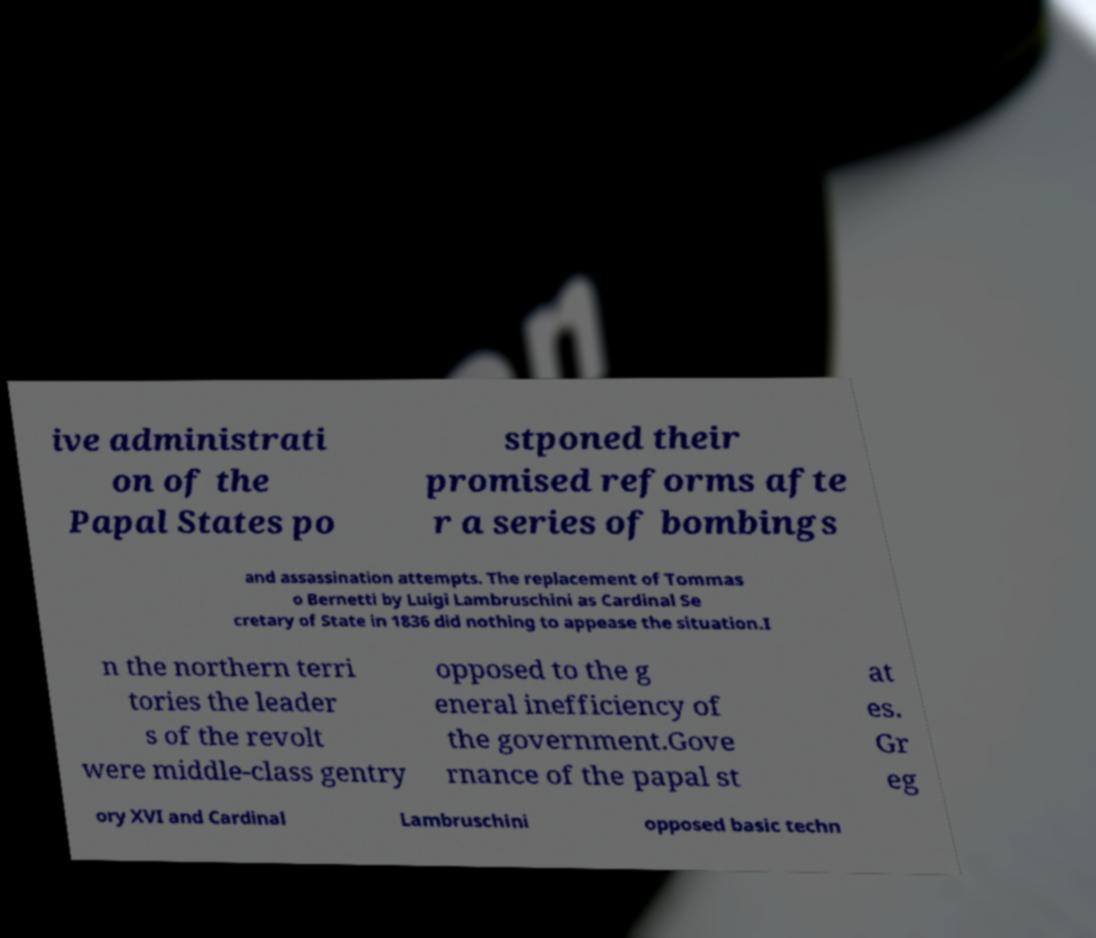What messages or text are displayed in this image? I need them in a readable, typed format. ive administrati on of the Papal States po stponed their promised reforms afte r a series of bombings and assassination attempts. The replacement of Tommas o Bernetti by Luigi Lambruschini as Cardinal Se cretary of State in 1836 did nothing to appease the situation.I n the northern terri tories the leader s of the revolt were middle-class gentry opposed to the g eneral inefficiency of the government.Gove rnance of the papal st at es. Gr eg ory XVI and Cardinal Lambruschini opposed basic techn 